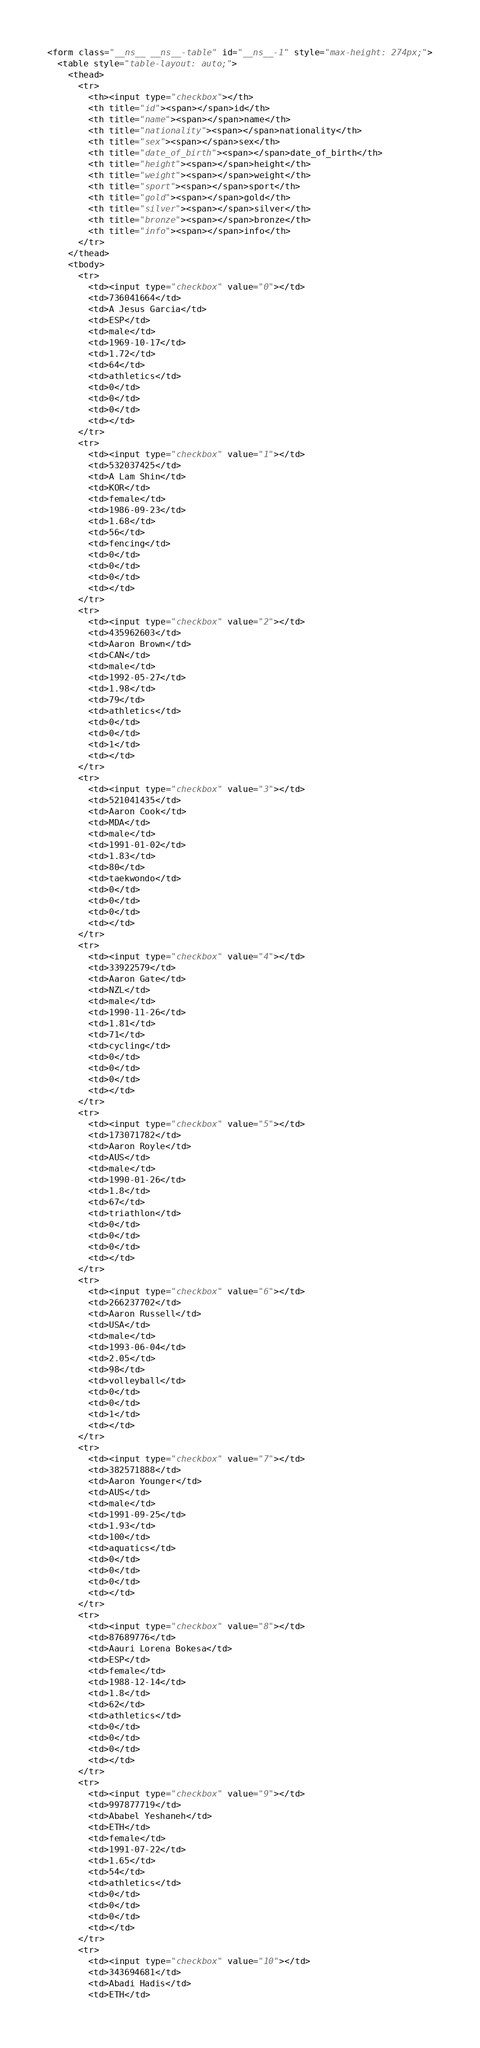<code> <loc_0><loc_0><loc_500><loc_500><_HTML_><form class="__ns__ __ns__-table" id="__ns__-1" style="max-height: 274px;">
  <table style="table-layout: auto;">
    <thead>
      <tr>
        <th><input type="checkbox"></th>
        <th title="id"><span></span>id</th>
        <th title="name"><span></span>name</th>
        <th title="nationality"><span></span>nationality</th>
        <th title="sex"><span></span>sex</th>
        <th title="date_of_birth"><span></span>date_of_birth</th>
        <th title="height"><span></span>height</th>
        <th title="weight"><span></span>weight</th>
        <th title="sport"><span></span>sport</th>
        <th title="gold"><span></span>gold</th>
        <th title="silver"><span></span>silver</th>
        <th title="bronze"><span></span>bronze</th>
        <th title="info"><span></span>info</th>
      </tr>
    </thead>
    <tbody>
      <tr>
        <td><input type="checkbox" value="0"></td>
        <td>736041664</td>
        <td>A Jesus Garcia</td>
        <td>ESP</td>
        <td>male</td>
        <td>1969-10-17</td>
        <td>1.72</td>
        <td>64</td>
        <td>athletics</td>
        <td>0</td>
        <td>0</td>
        <td>0</td>
        <td></td>
      </tr>
      <tr>
        <td><input type="checkbox" value="1"></td>
        <td>532037425</td>
        <td>A Lam Shin</td>
        <td>KOR</td>
        <td>female</td>
        <td>1986-09-23</td>
        <td>1.68</td>
        <td>56</td>
        <td>fencing</td>
        <td>0</td>
        <td>0</td>
        <td>0</td>
        <td></td>
      </tr>
      <tr>
        <td><input type="checkbox" value="2"></td>
        <td>435962603</td>
        <td>Aaron Brown</td>
        <td>CAN</td>
        <td>male</td>
        <td>1992-05-27</td>
        <td>1.98</td>
        <td>79</td>
        <td>athletics</td>
        <td>0</td>
        <td>0</td>
        <td>1</td>
        <td></td>
      </tr>
      <tr>
        <td><input type="checkbox" value="3"></td>
        <td>521041435</td>
        <td>Aaron Cook</td>
        <td>MDA</td>
        <td>male</td>
        <td>1991-01-02</td>
        <td>1.83</td>
        <td>80</td>
        <td>taekwondo</td>
        <td>0</td>
        <td>0</td>
        <td>0</td>
        <td></td>
      </tr>
      <tr>
        <td><input type="checkbox" value="4"></td>
        <td>33922579</td>
        <td>Aaron Gate</td>
        <td>NZL</td>
        <td>male</td>
        <td>1990-11-26</td>
        <td>1.81</td>
        <td>71</td>
        <td>cycling</td>
        <td>0</td>
        <td>0</td>
        <td>0</td>
        <td></td>
      </tr>
      <tr>
        <td><input type="checkbox" value="5"></td>
        <td>173071782</td>
        <td>Aaron Royle</td>
        <td>AUS</td>
        <td>male</td>
        <td>1990-01-26</td>
        <td>1.8</td>
        <td>67</td>
        <td>triathlon</td>
        <td>0</td>
        <td>0</td>
        <td>0</td>
        <td></td>
      </tr>
      <tr>
        <td><input type="checkbox" value="6"></td>
        <td>266237702</td>
        <td>Aaron Russell</td>
        <td>USA</td>
        <td>male</td>
        <td>1993-06-04</td>
        <td>2.05</td>
        <td>98</td>
        <td>volleyball</td>
        <td>0</td>
        <td>0</td>
        <td>1</td>
        <td></td>
      </tr>
      <tr>
        <td><input type="checkbox" value="7"></td>
        <td>382571888</td>
        <td>Aaron Younger</td>
        <td>AUS</td>
        <td>male</td>
        <td>1991-09-25</td>
        <td>1.93</td>
        <td>100</td>
        <td>aquatics</td>
        <td>0</td>
        <td>0</td>
        <td>0</td>
        <td></td>
      </tr>
      <tr>
        <td><input type="checkbox" value="8"></td>
        <td>87689776</td>
        <td>Aauri Lorena Bokesa</td>
        <td>ESP</td>
        <td>female</td>
        <td>1988-12-14</td>
        <td>1.8</td>
        <td>62</td>
        <td>athletics</td>
        <td>0</td>
        <td>0</td>
        <td>0</td>
        <td></td>
      </tr>
      <tr>
        <td><input type="checkbox" value="9"></td>
        <td>997877719</td>
        <td>Ababel Yeshaneh</td>
        <td>ETH</td>
        <td>female</td>
        <td>1991-07-22</td>
        <td>1.65</td>
        <td>54</td>
        <td>athletics</td>
        <td>0</td>
        <td>0</td>
        <td>0</td>
        <td></td>
      </tr>
      <tr>
        <td><input type="checkbox" value="10"></td>
        <td>343694681</td>
        <td>Abadi Hadis</td>
        <td>ETH</td></code> 